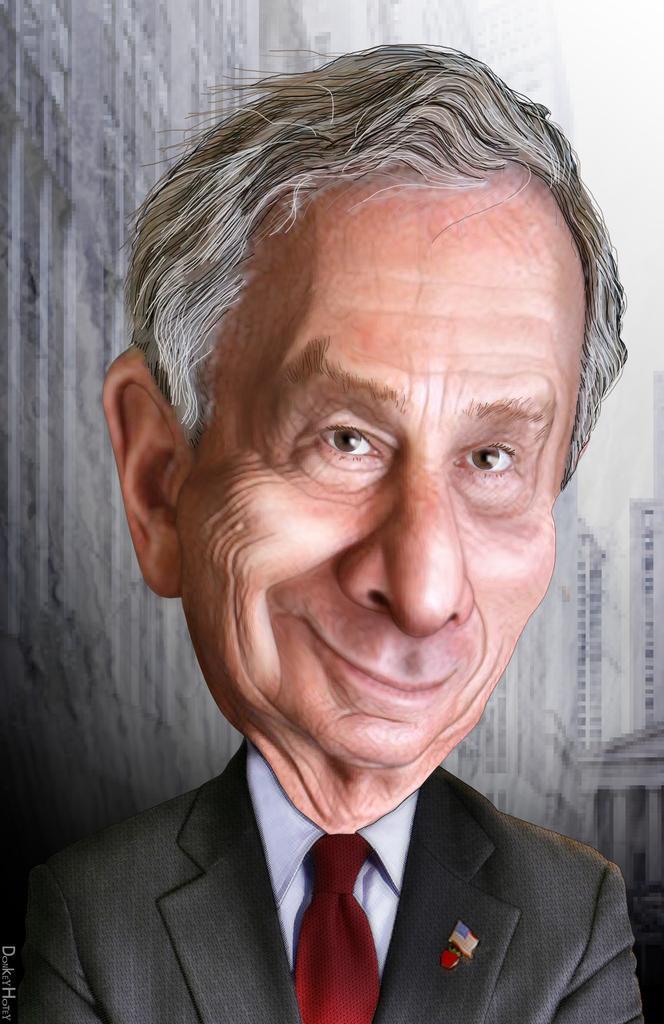Could you give a brief overview of what you see in this image? In this image we can see an edited picture of a person wearing a coat and tie. In the background, we can see a group of buildings, the sky and some text. 